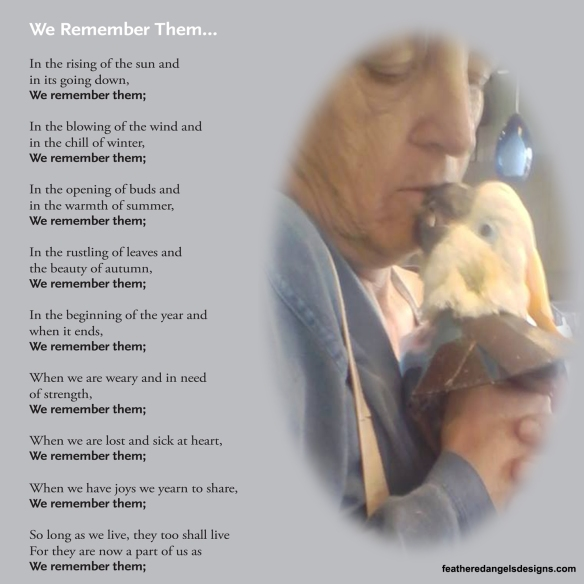What does the recurring phrase 'We remember them' in the poem add to the interpretation of the image? The recurring phrase 'We remember them' in the poem adds a powerful layer of meaning to the interpretation of the image. It reinforces the themes of memory and enduring affection, suggesting that the relationship between the person and the bird is one that will be cherished and remembered long after the moment captured in the image. This phrase also echoes the universal experience of loss and reflection, making the image not just a personal tribute but a shared reminder of the importance of holding on to the memories of those we love.  Let's delve into the potential backstory. How might the bird have come into the person's life, and what impact could it have had? The bird might have come into the person's life during a challenging period, perhaps offering companionship and solace when it was most needed. It could have been a rescued bird, a gift from a loved one, or a serendipitous encounter that blossomed into a deep and lasting friendship. The bird's impact on the person's life could be profound, providing daily joy, comfort, and a sense of purpose. This relationship might have taught the person about the simplicity of happiness, the importance of living in the moment, and the beauty of connecting with other beings, all of which are sentiments echoed in the poem.  If you were to write a poem inspired by this image, what would the first few lines be? In the gentle brush of feathered warmth,
A whisper of love so deep it charms.
In quiet moments, hearts entwine,
In memories carved by the sands of time.  Can you suggest a realistic scenario involving the image? A realistic scenario involving this image might depict an elderly person who has raised the bird from a chick. Over the years, they developed a cherished daily routine of spending time together, sharing a bond that filled the person's days with joy and purpose. Now, the person might be preparing for a move to a new home, where pets are not allowed, and this kiss represents a heartfelt and sorrowful goodbye, as they take a moment to remember their faithful companion and the beautiful times they've shared.  Describe another realistic moment shown in the image. In another realistic moment, the person might be reminiscing about the past as they tenderly kiss their bird. This interaction could be part of their daily routine, a quiet affirmation of the love and trust they share. The soft expression on the person's face and the gentle way they hold the bird speak volumes about the comfort and happiness they've found in each other's company, serving as a beautiful testament to the enduring bonds formed with our animal companions. 